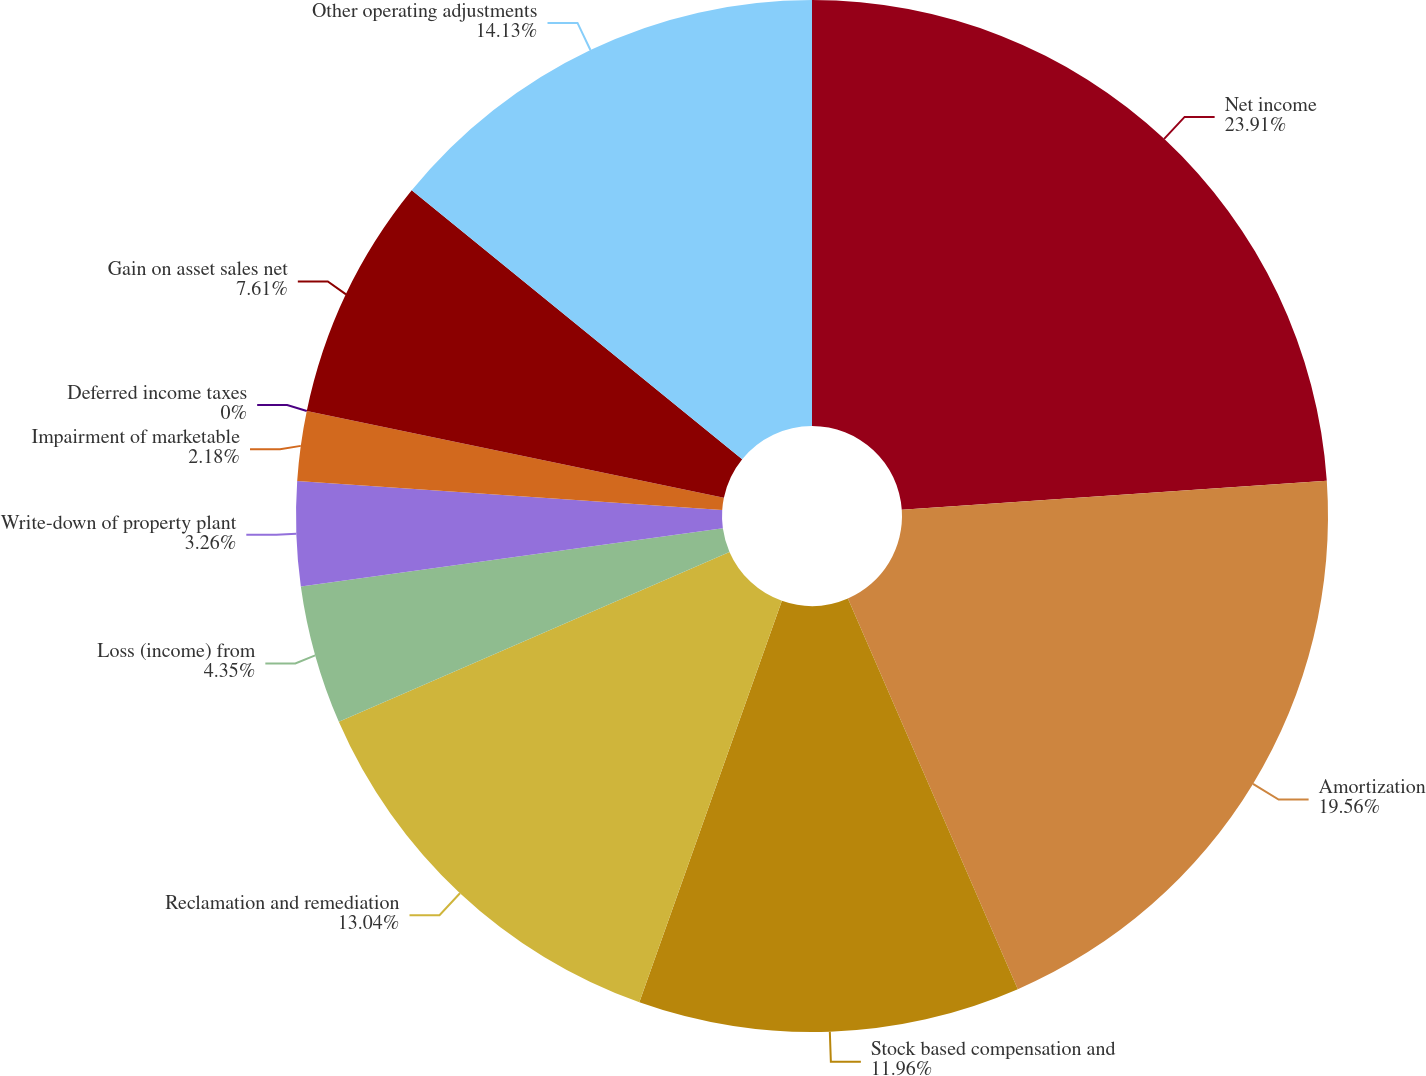Convert chart to OTSL. <chart><loc_0><loc_0><loc_500><loc_500><pie_chart><fcel>Net income<fcel>Amortization<fcel>Stock based compensation and<fcel>Reclamation and remediation<fcel>Loss (income) from<fcel>Write-down of property plant<fcel>Impairment of marketable<fcel>Deferred income taxes<fcel>Gain on asset sales net<fcel>Other operating adjustments<nl><fcel>23.91%<fcel>19.56%<fcel>11.96%<fcel>13.04%<fcel>4.35%<fcel>3.26%<fcel>2.18%<fcel>0.0%<fcel>7.61%<fcel>14.13%<nl></chart> 